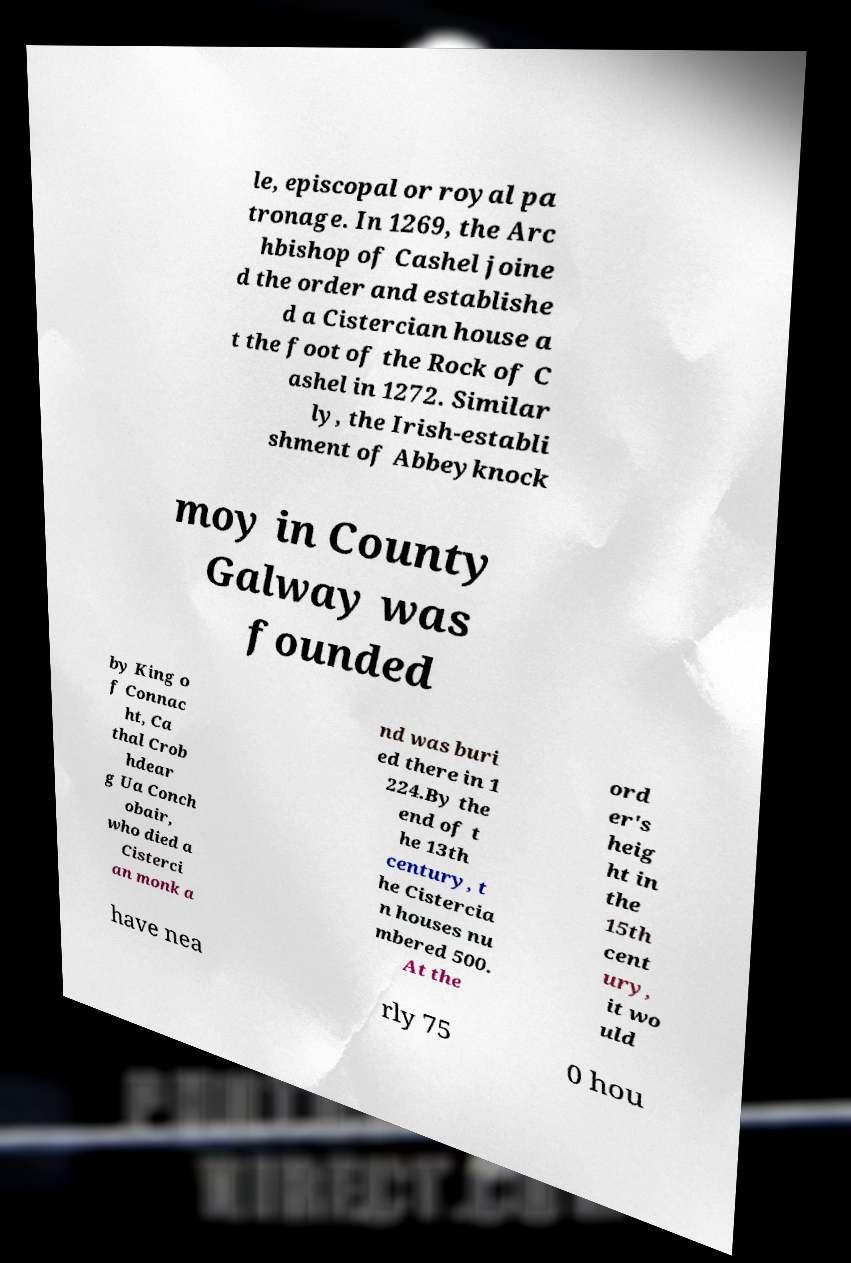Can you accurately transcribe the text from the provided image for me? le, episcopal or royal pa tronage. In 1269, the Arc hbishop of Cashel joine d the order and establishe d a Cistercian house a t the foot of the Rock of C ashel in 1272. Similar ly, the Irish-establi shment of Abbeyknock moy in County Galway was founded by King o f Connac ht, Ca thal Crob hdear g Ua Conch obair, who died a Cisterci an monk a nd was buri ed there in 1 224.By the end of t he 13th century, t he Cistercia n houses nu mbered 500. At the ord er's heig ht in the 15th cent ury, it wo uld have nea rly 75 0 hou 